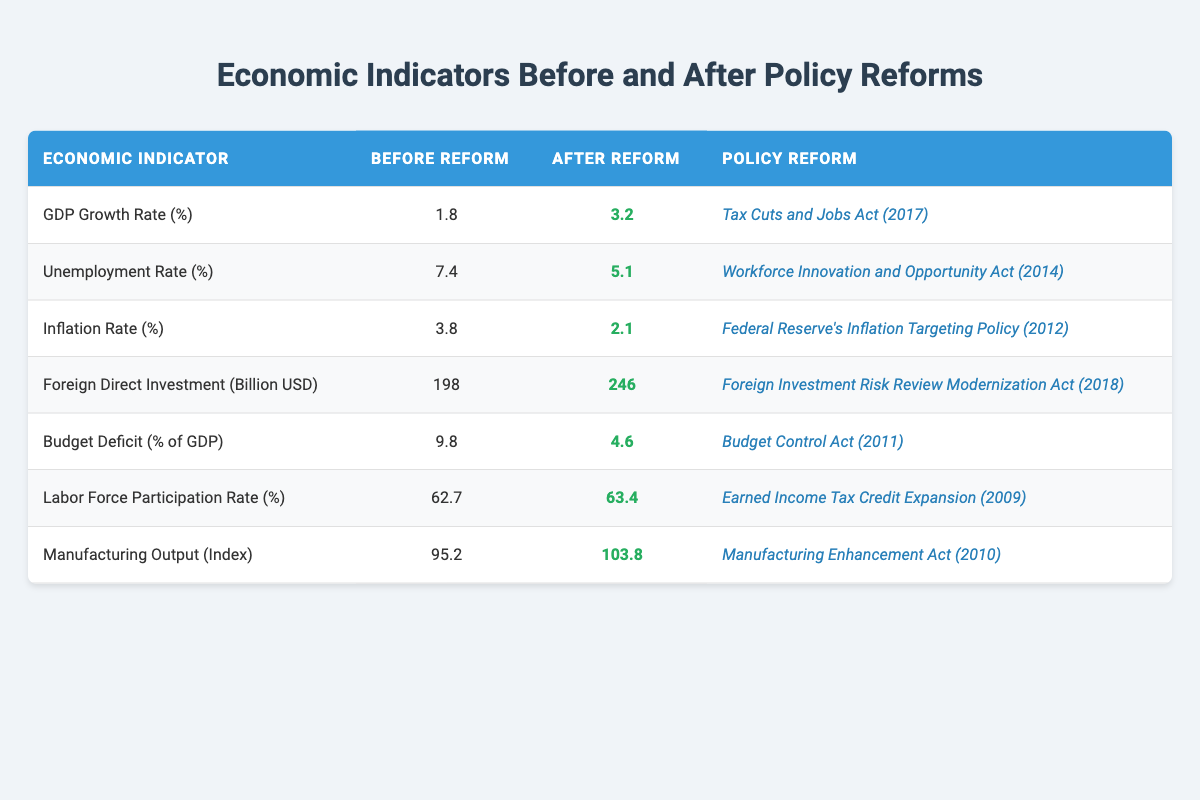What was the GDP Growth Rate before the reform? The table shows that the GDP Growth Rate before the reform was listed as 1.8%.
Answer: 1.8% What is the difference in the unemployment rate before and after the reform? The unemployment rate before the reform was 7.4%, and after the reform, it was 5.1%. The difference is calculated by subtracting 5.1% from 7.4%, which gives 2.3%.
Answer: 2.3% Did the inflation rate decrease as a result of the reform? The inflation rate before the reform was 3.8%, and after the reform, it was 2.1%. Since 2.1% is less than 3.8%, it confirms a decrease.
Answer: Yes What was the percentage change in Foreign Direct Investment after the reform? The Foreign Direct Investment before the reform was 198 billion USD and after the reform was 246 billion USD. To calculate the percentage change, subtract 198 from 246 (which equals 48), then divide by 198 and multiply by 100, yielding approximately 24.24%.
Answer: 24.24% Which economic indicator had the largest improvement after the reform? To determine the largest improvement, compare the differences between "After Reform" and "Before Reform" for each indicator. The largest increase is observed in the GDP Growth Rate, with a change from 1.8% to 3.2%, which is an improvement of 1.4%.
Answer: GDP Growth Rate What is the average Labor Force Participation Rate before the reform based on the table? The table provides only one value for the Labor Force Participation Rate before the reform at 62.7%. Hence, the average is simply this single value, which is 62.7%.
Answer: 62.7% Was there an increase in Manufacturing Output after the reform? The table displays Manufacturing Output at 95.2 before the reform and 103.8 after the reform. Since 103.8 is greater than 95.2, this indicates an increase.
Answer: Yes What was the overall trend observed in the Budget Deficit (% of GDP) after the reform? Before the reform, the Budget Deficit was 9.8% of GDP, and after it dropped to 4.6%. This shows a downward trend or improvement.
Answer: Downward trend 